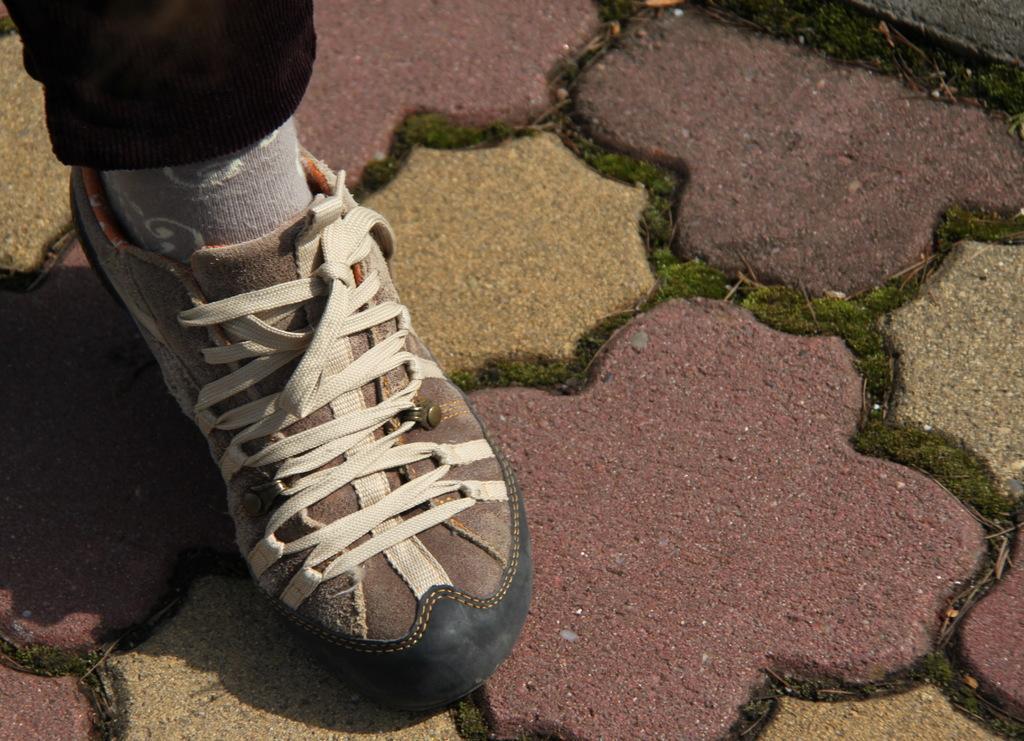Can you describe this image briefly? In this image we can see a person's leg wearing socks and shoes is on the ground. 